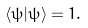<formula> <loc_0><loc_0><loc_500><loc_500>\langle \psi | \psi \rangle = 1 .</formula> 